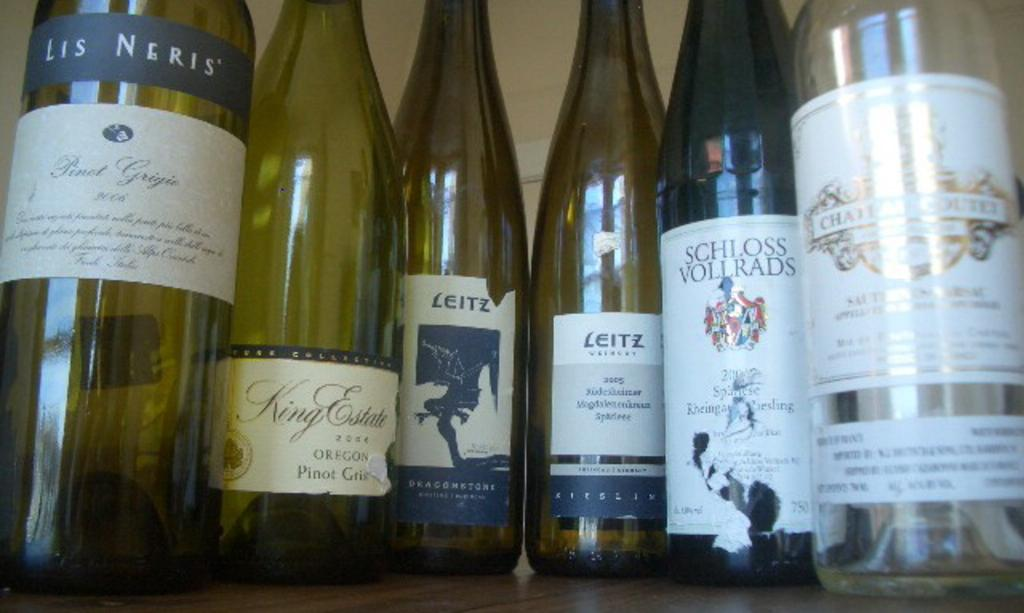<image>
Offer a succinct explanation of the picture presented. bottle of wine including LEITZ and Lis Neris 